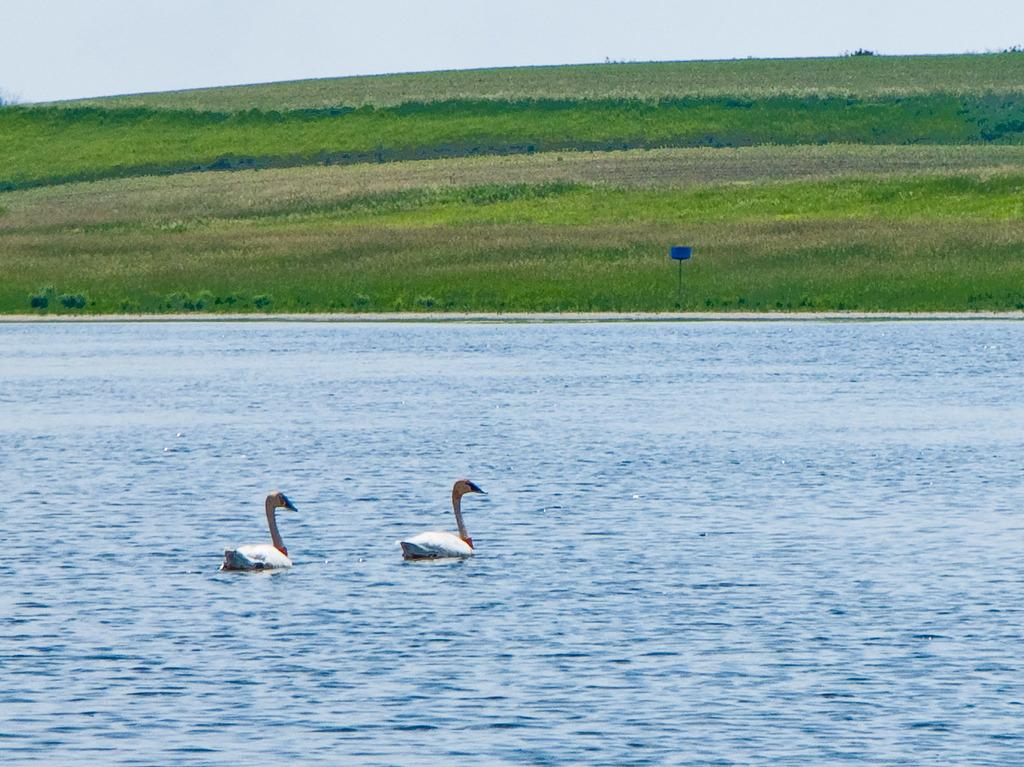What animals can be seen in the water in the image? There are two swans in the water in the image. What type of vegetation is visible in the background of the image? There are plants and shrubs in the background of the image. What type of terrain is visible in the background of the image? There is a grassy field in the background of the image. What is the condition of the sky in the image? The sky is cloudy in the image. What type of scale can be seen in the image? There is no scale present in the image. What is the quartz used for in the image? There is no quartz present in the image. 